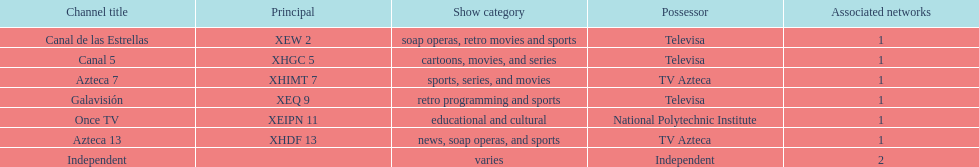What is the total number of affiliates among all the networks? 8. 